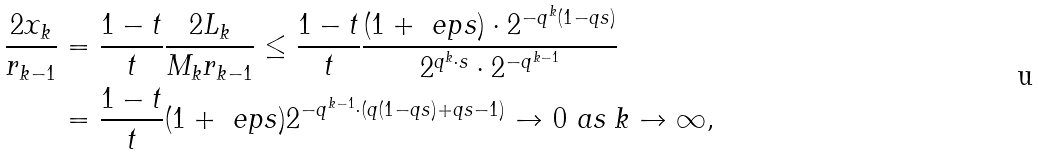<formula> <loc_0><loc_0><loc_500><loc_500>\frac { 2 x _ { k } } { r _ { k - 1 } } & = \frac { 1 - t } t \frac { 2 L _ { k } } { M _ { k } r _ { k - 1 } } \leq \frac { 1 - t } t \frac { ( 1 + \ e p s ) \cdot 2 ^ { - q ^ { k } ( 1 - q s ) } } { 2 ^ { q ^ { k } \cdot s } \cdot 2 ^ { - q ^ { k - 1 } } } \\ & = \frac { 1 - t } { t } ( 1 + \ e p s ) 2 ^ { - q ^ { k - 1 } \cdot ( q ( 1 - q s ) + q s - 1 ) } \to 0 \text { as } k \to \infty ,</formula> 